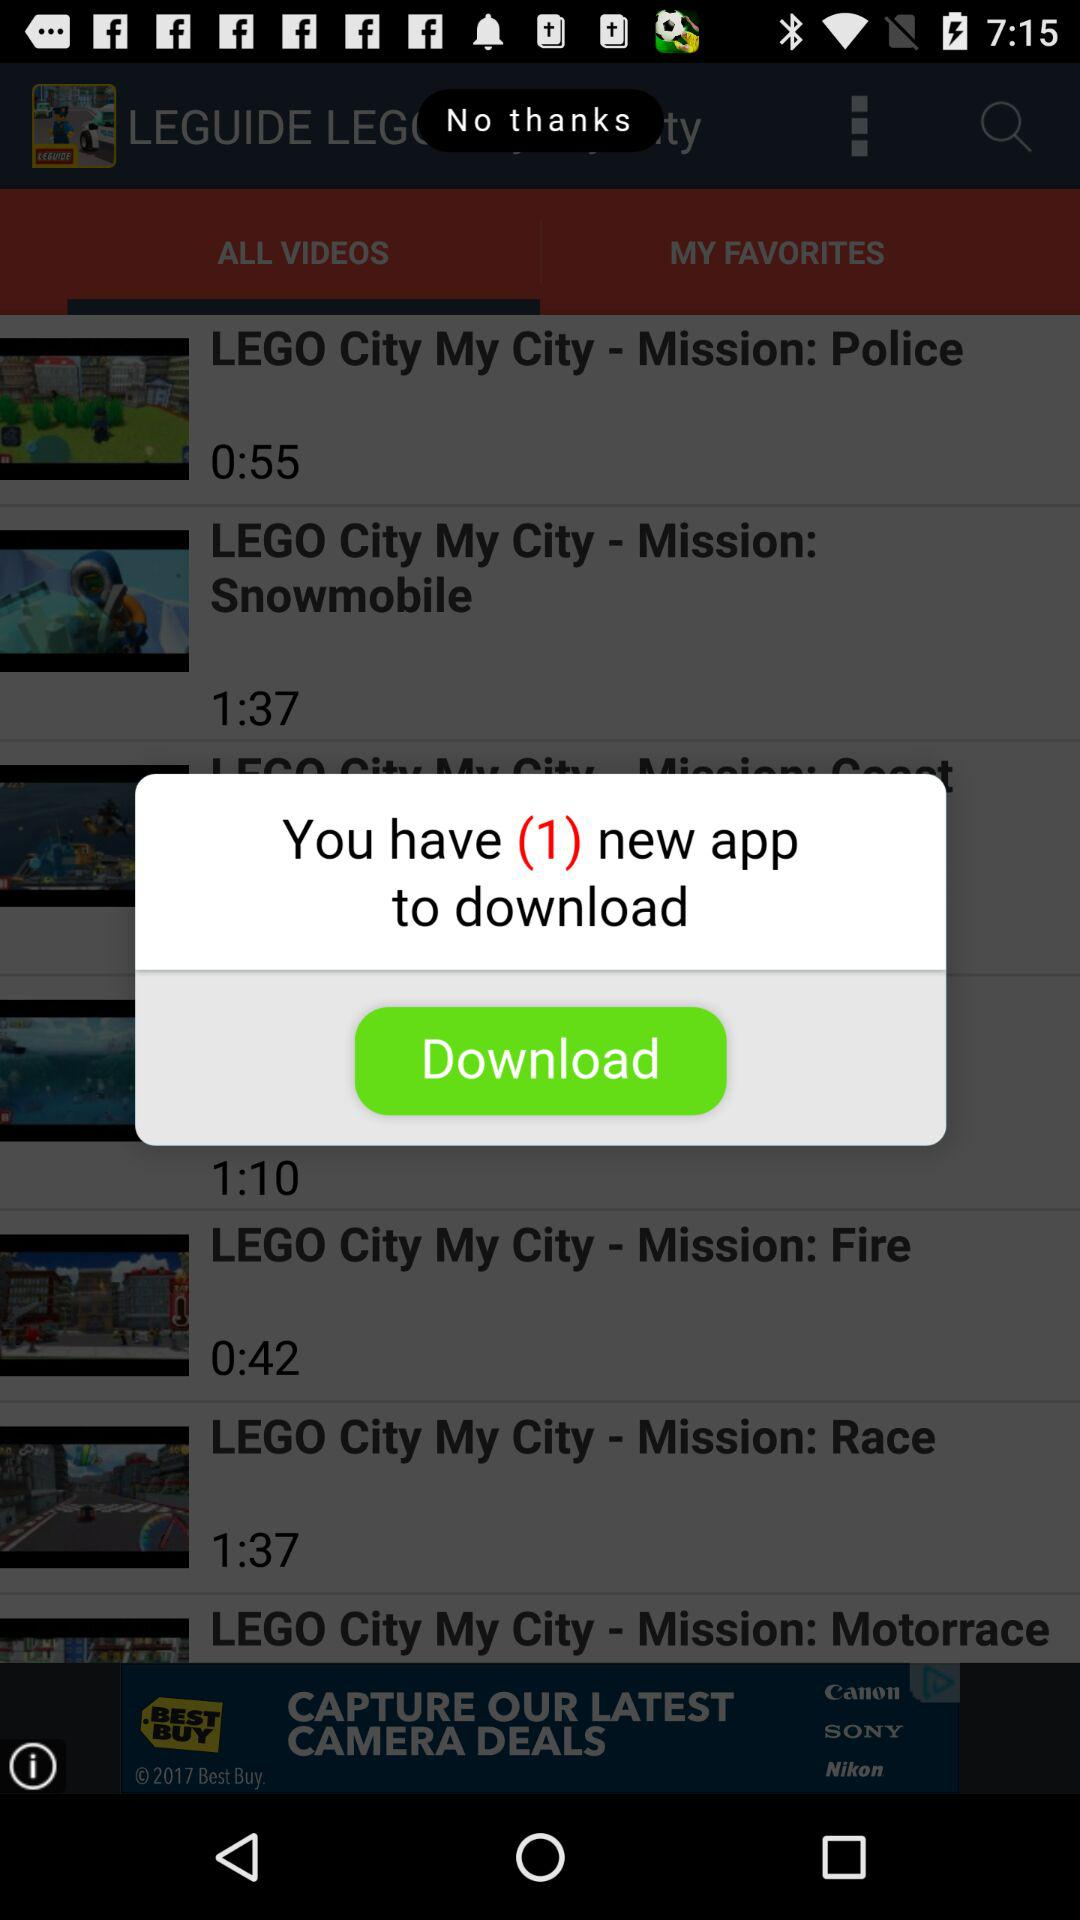How long is the video "LEGO City My City - Mission: Snowmobile"? The video "LEGO City My City - Mission: Snowmobile" is 1 minute 37 seconds long. 